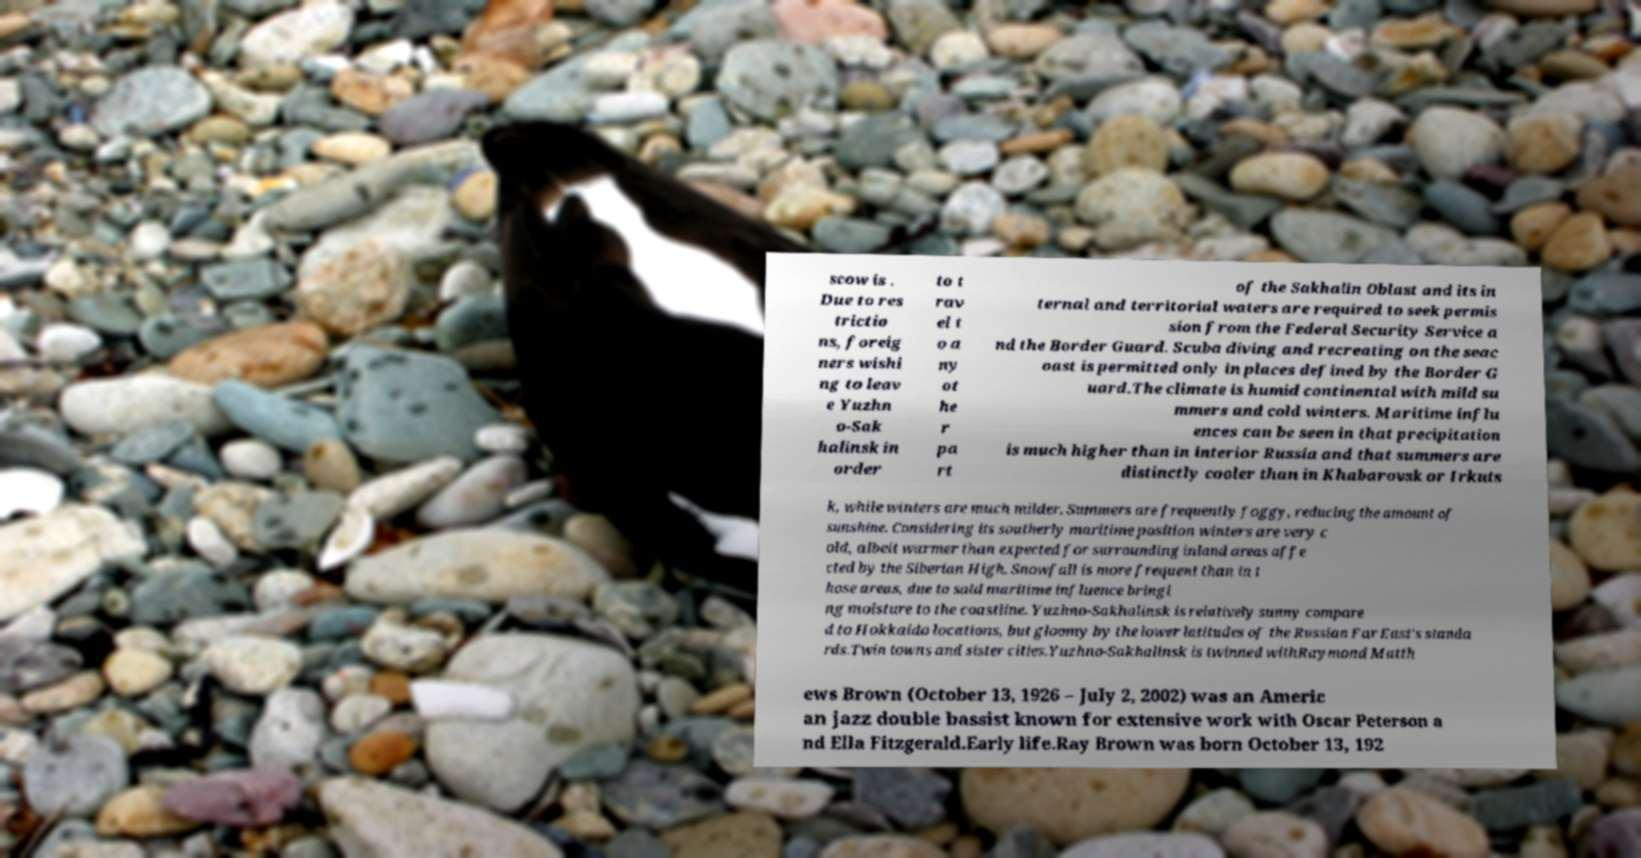For documentation purposes, I need the text within this image transcribed. Could you provide that? scow is . Due to res trictio ns, foreig ners wishi ng to leav e Yuzhn o-Sak halinsk in order to t rav el t o a ny ot he r pa rt of the Sakhalin Oblast and its in ternal and territorial waters are required to seek permis sion from the Federal Security Service a nd the Border Guard. Scuba diving and recreating on the seac oast is permitted only in places defined by the Border G uard.The climate is humid continental with mild su mmers and cold winters. Maritime influ ences can be seen in that precipitation is much higher than in interior Russia and that summers are distinctly cooler than in Khabarovsk or Irkuts k, while winters are much milder. Summers are frequently foggy, reducing the amount of sunshine. Considering its southerly maritime position winters are very c old, albeit warmer than expected for surrounding inland areas affe cted by the Siberian High. Snowfall is more frequent than in t hose areas, due to said maritime influence bringi ng moisture to the coastline. Yuzhno-Sakhalinsk is relatively sunny compare d to Hokkaido locations, but gloomy by the lower latitudes of the Russian Far East's standa rds.Twin towns and sister cities.Yuzhno-Sakhalinsk is twinned withRaymond Matth ews Brown (October 13, 1926 – July 2, 2002) was an Americ an jazz double bassist known for extensive work with Oscar Peterson a nd Ella Fitzgerald.Early life.Ray Brown was born October 13, 192 